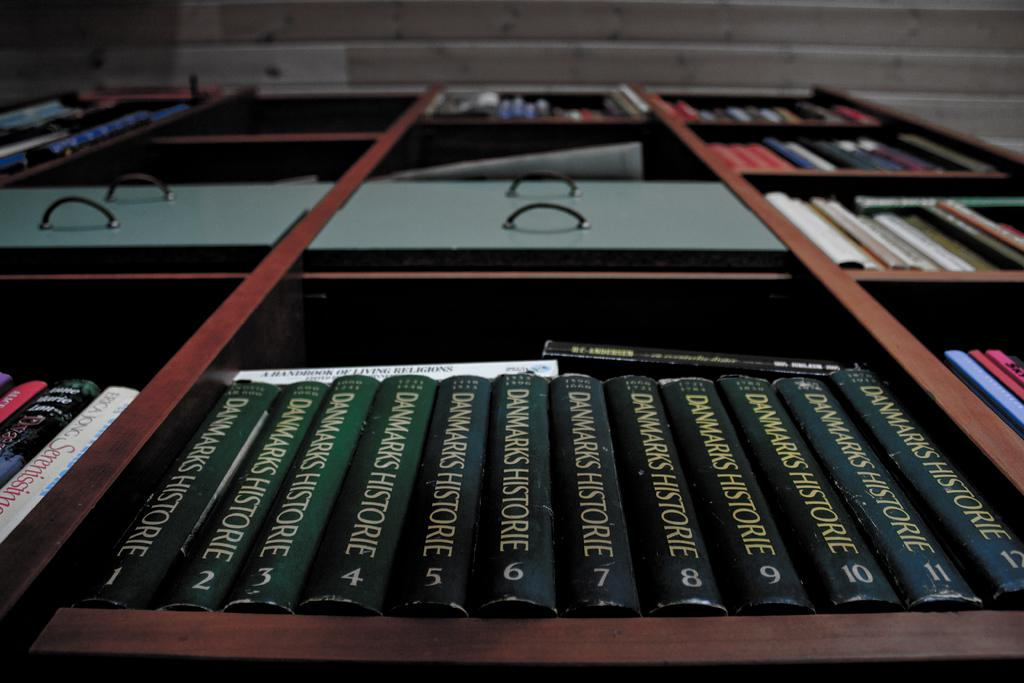<image>
Share a concise interpretation of the image provided. A view looking up from the bottom of a bookshelf starting at the full series of Danmarks Historie. 